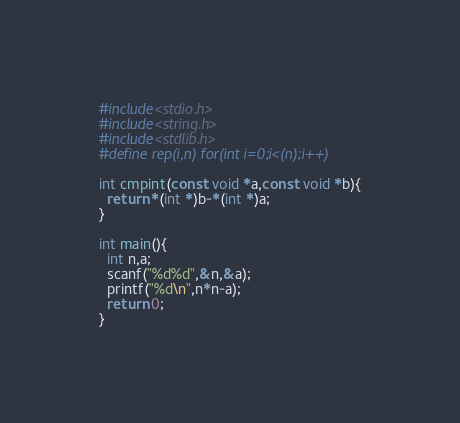<code> <loc_0><loc_0><loc_500><loc_500><_C_>#include<stdio.h>
#include<string.h>
#include<stdlib.h>
#define rep(i,n) for(int i=0;i<(n);i++)

int cmpint(const void *a,const void *b){
  return *(int *)b-*(int *)a;
}

int main(){
  int n,a;
  scanf("%d%d",&n,&a);
  printf("%d\n",n*n-a);
  return 0;
}
</code> 